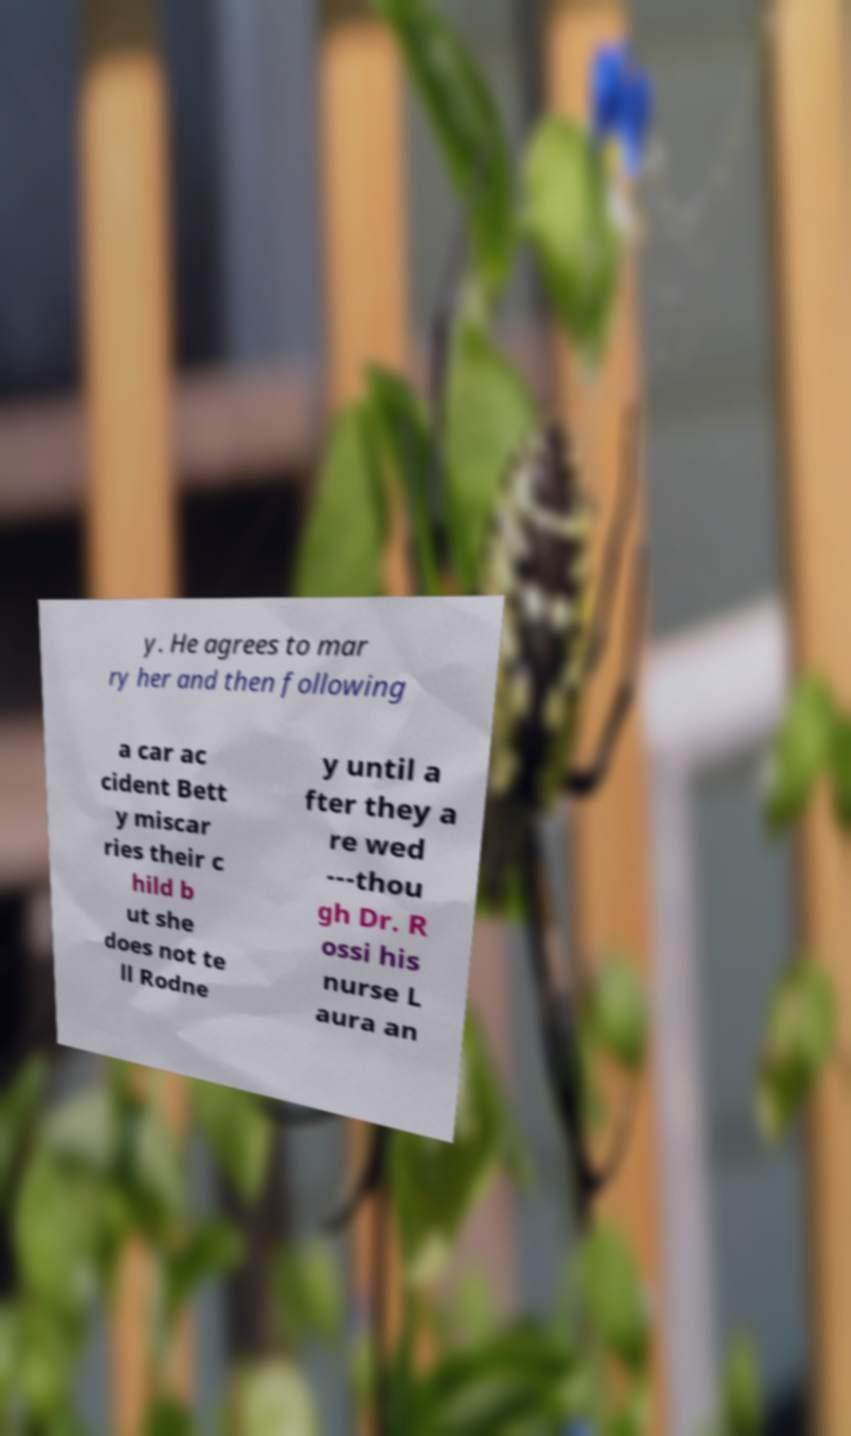For documentation purposes, I need the text within this image transcribed. Could you provide that? y. He agrees to mar ry her and then following a car ac cident Bett y miscar ries their c hild b ut she does not te ll Rodne y until a fter they a re wed ---thou gh Dr. R ossi his nurse L aura an 